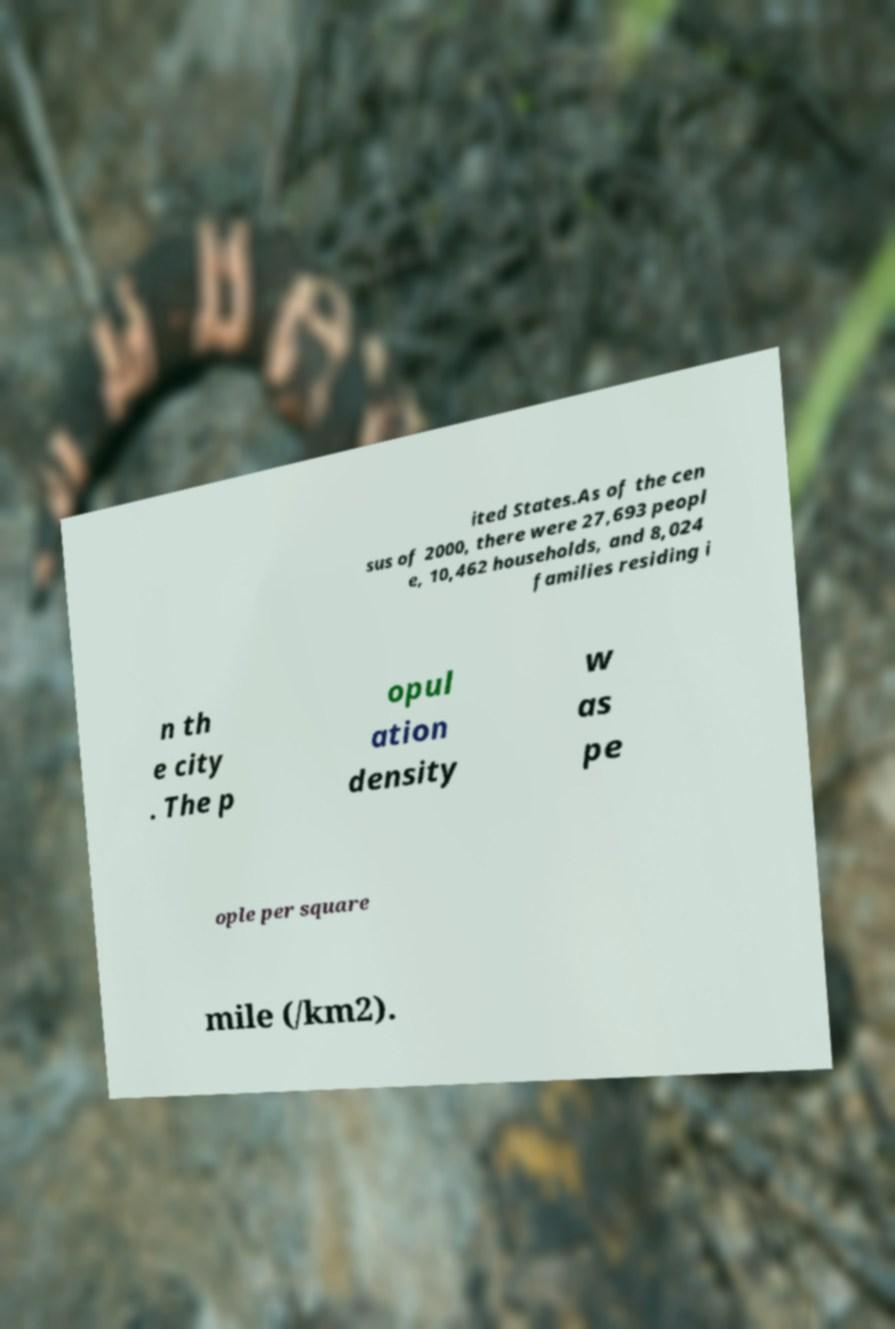Can you accurately transcribe the text from the provided image for me? ited States.As of the cen sus of 2000, there were 27,693 peopl e, 10,462 households, and 8,024 families residing i n th e city . The p opul ation density w as pe ople per square mile (/km2). 